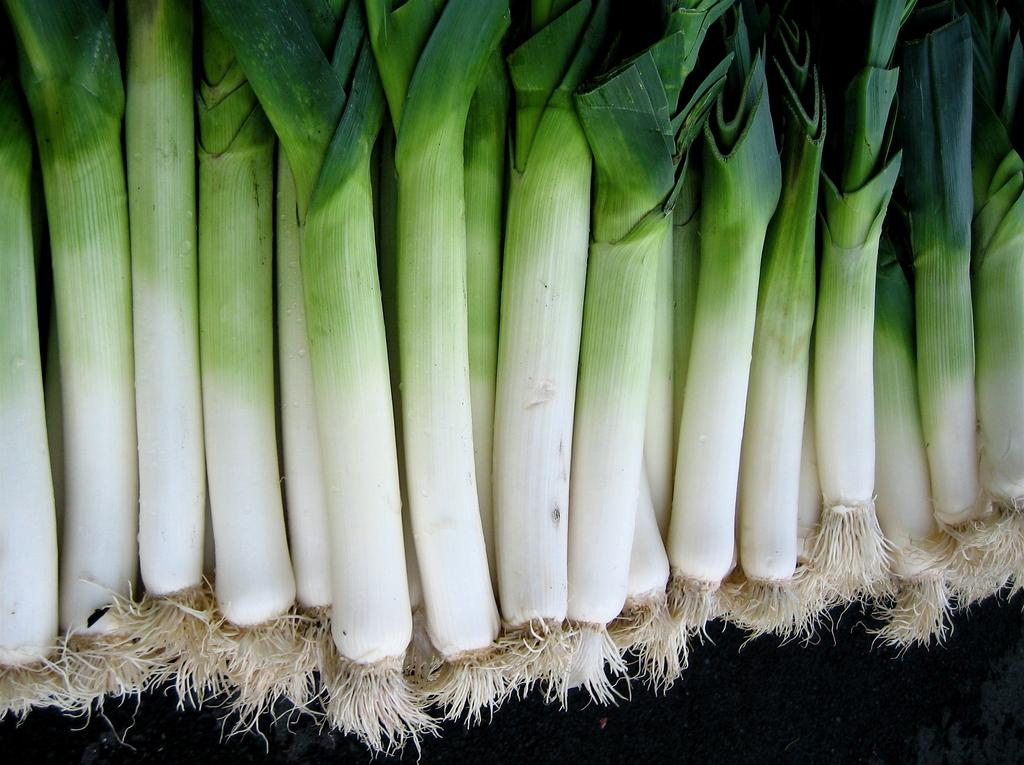What type of vegetables are in the image? There are spring onions in the image. What is the color of the surface on which the spring onions are placed? The surface is dark. What type of hat is the minister wearing in the image? There is no minister or hat present in the image; it only features spring onions on a dark surface. 